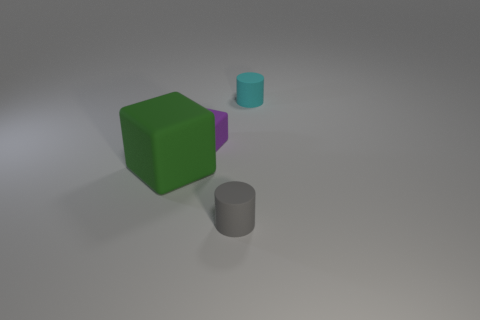Do the tiny cube and the tiny cylinder that is behind the gray rubber cylinder have the same material?
Make the answer very short. Yes. Is the number of large green rubber cubes to the left of the tiny cyan cylinder greater than the number of cyan rubber things?
Provide a short and direct response. No. Are there any other things that have the same size as the purple block?
Provide a short and direct response. Yes. Does the large rubber block have the same color as the tiny rubber thing in front of the small rubber block?
Provide a short and direct response. No. Are there an equal number of cylinders on the right side of the tiny cyan rubber object and big matte blocks in front of the green rubber object?
Offer a terse response. Yes. What material is the cylinder that is left of the tiny cyan cylinder?
Give a very brief answer. Rubber. What number of things are small cyan rubber cylinders that are behind the large matte object or cyan things?
Ensure brevity in your answer.  1. How many other things are there of the same shape as the green object?
Make the answer very short. 1. There is a object on the right side of the small gray rubber cylinder; is it the same shape as the big green object?
Your answer should be compact. No. Are there any small objects right of the tiny gray thing?
Your answer should be compact. Yes. 